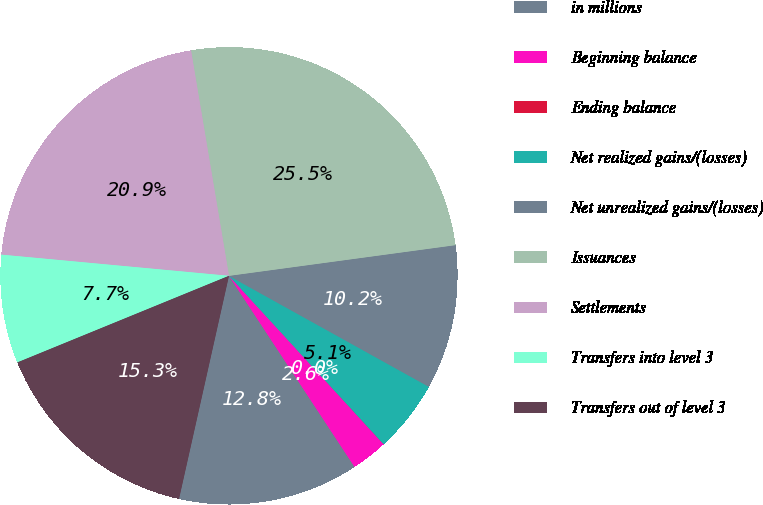Convert chart to OTSL. <chart><loc_0><loc_0><loc_500><loc_500><pie_chart><fcel>in millions<fcel>Beginning balance<fcel>Ending balance<fcel>Net realized gains/(losses)<fcel>Net unrealized gains/(losses)<fcel>Issuances<fcel>Settlements<fcel>Transfers into level 3<fcel>Transfers out of level 3<nl><fcel>12.76%<fcel>2.56%<fcel>0.01%<fcel>5.11%<fcel>10.21%<fcel>25.51%<fcel>20.87%<fcel>7.66%<fcel>15.31%<nl></chart> 